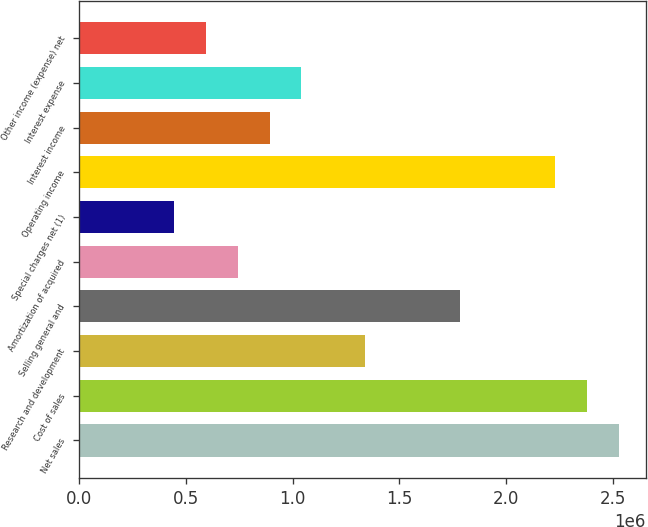Convert chart to OTSL. <chart><loc_0><loc_0><loc_500><loc_500><bar_chart><fcel>Net sales<fcel>Cost of sales<fcel>Research and development<fcel>Selling general and<fcel>Amortization of acquired<fcel>Special charges net (1)<fcel>Operating income<fcel>Interest income<fcel>Interest expense<fcel>Other income (expense) net<nl><fcel>2.52825e+06<fcel>2.37953e+06<fcel>1.33848e+06<fcel>1.78465e+06<fcel>743603<fcel>446162<fcel>2.23081e+06<fcel>892324<fcel>1.04104e+06<fcel>594883<nl></chart> 